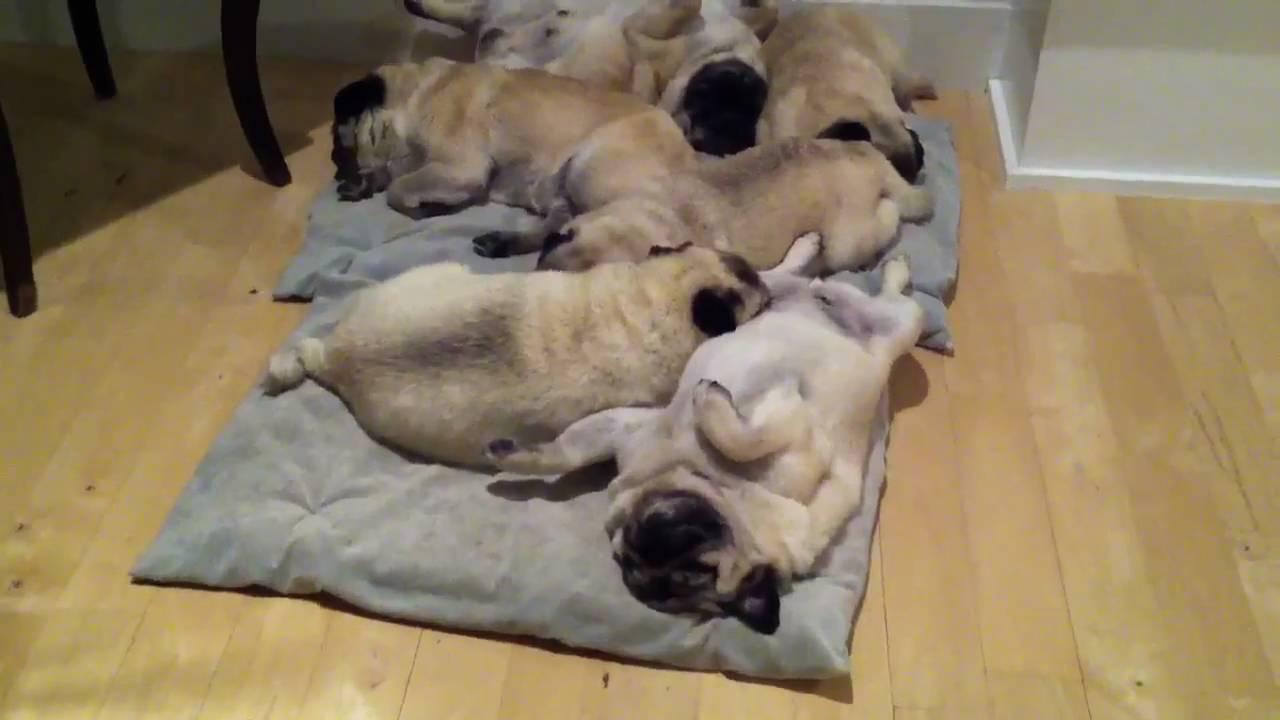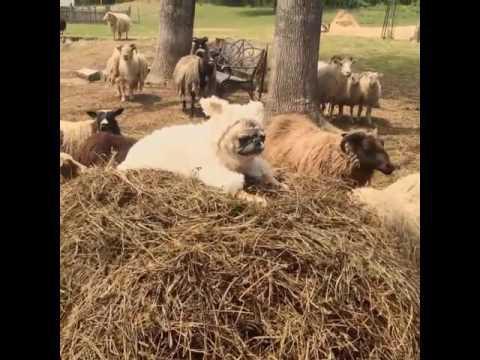The first image is the image on the left, the second image is the image on the right. Analyze the images presented: Is the assertion "Pugs are huddled together on a gray tiled floor" valid? Answer yes or no. No. The first image is the image on the left, the second image is the image on the right. Evaluate the accuracy of this statement regarding the images: "A group of brown boxer puppies are indoors in one of the images, and at least two of those are looking at the camera.". Is it true? Answer yes or no. No. 